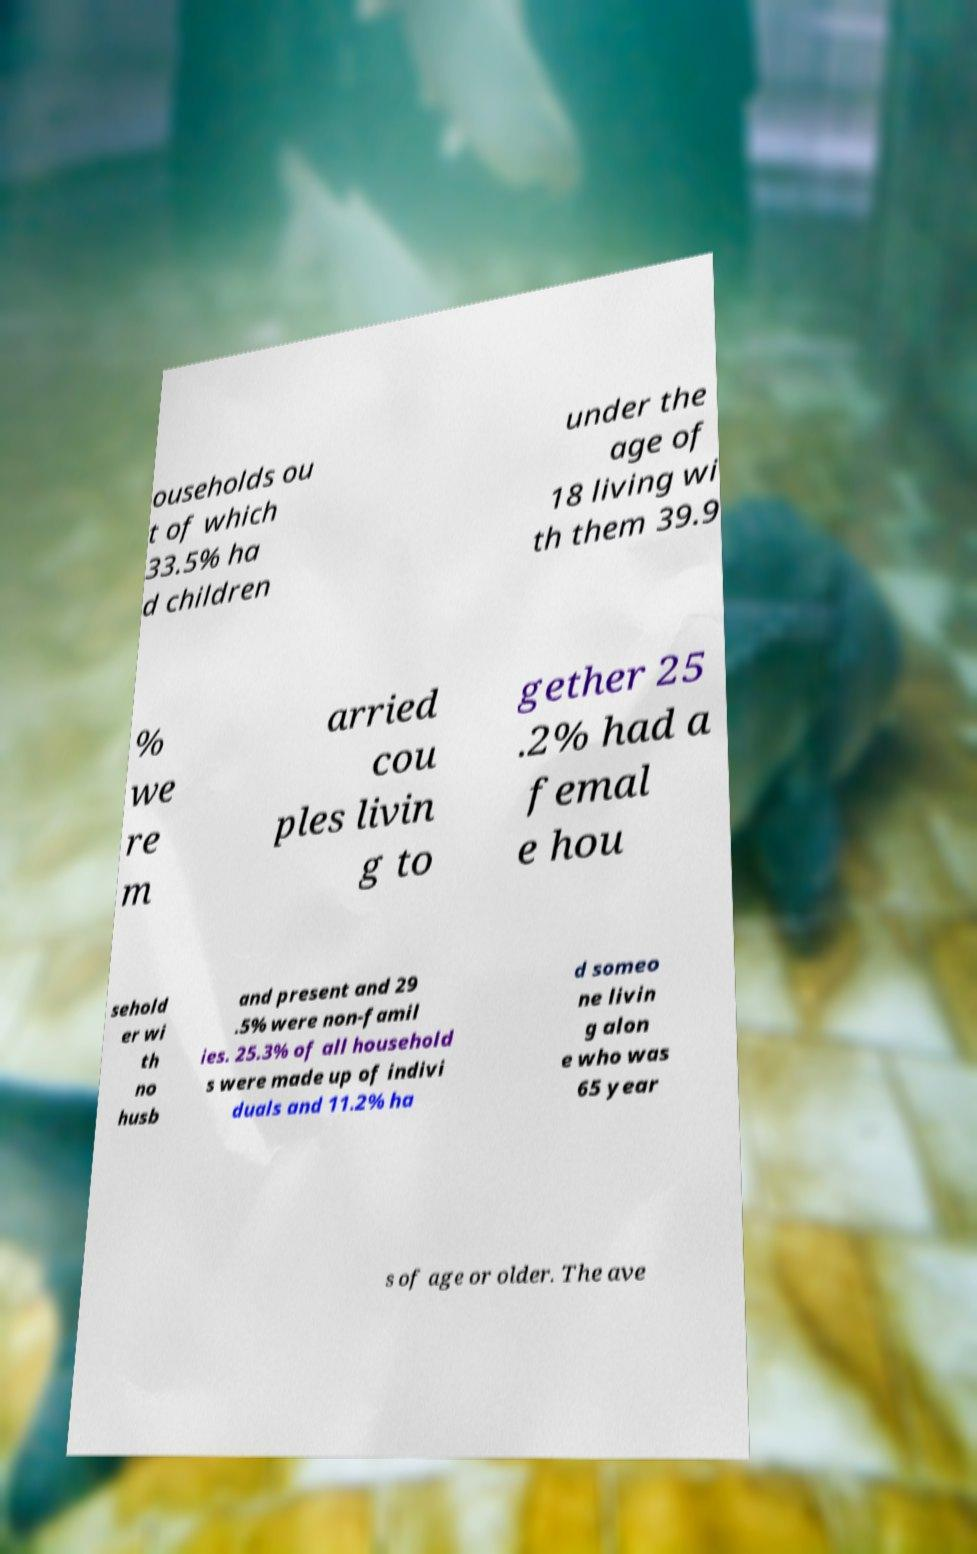I need the written content from this picture converted into text. Can you do that? ouseholds ou t of which 33.5% ha d children under the age of 18 living wi th them 39.9 % we re m arried cou ples livin g to gether 25 .2% had a femal e hou sehold er wi th no husb and present and 29 .5% were non-famil ies. 25.3% of all household s were made up of indivi duals and 11.2% ha d someo ne livin g alon e who was 65 year s of age or older. The ave 